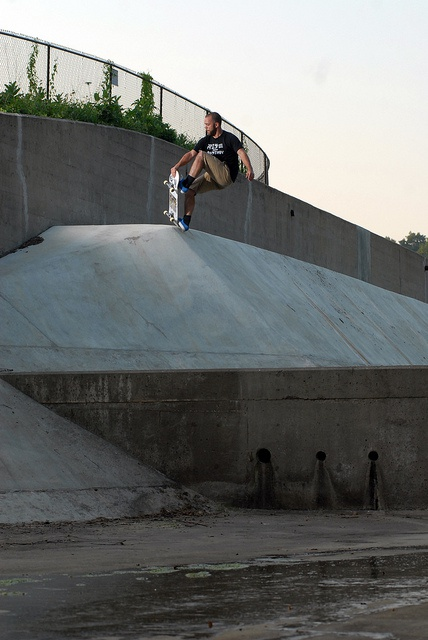Describe the objects in this image and their specific colors. I can see people in white, black, gray, brown, and maroon tones and skateboard in white, darkgray, lightgray, gray, and black tones in this image. 